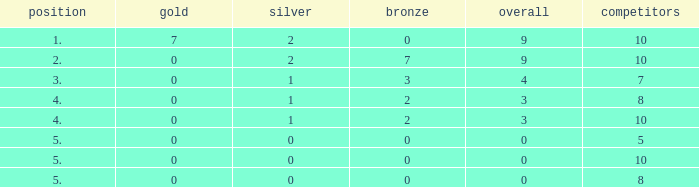What is listed as the highest Participants that also have a Rank of 5, and Silver that's smaller than 0? None. 